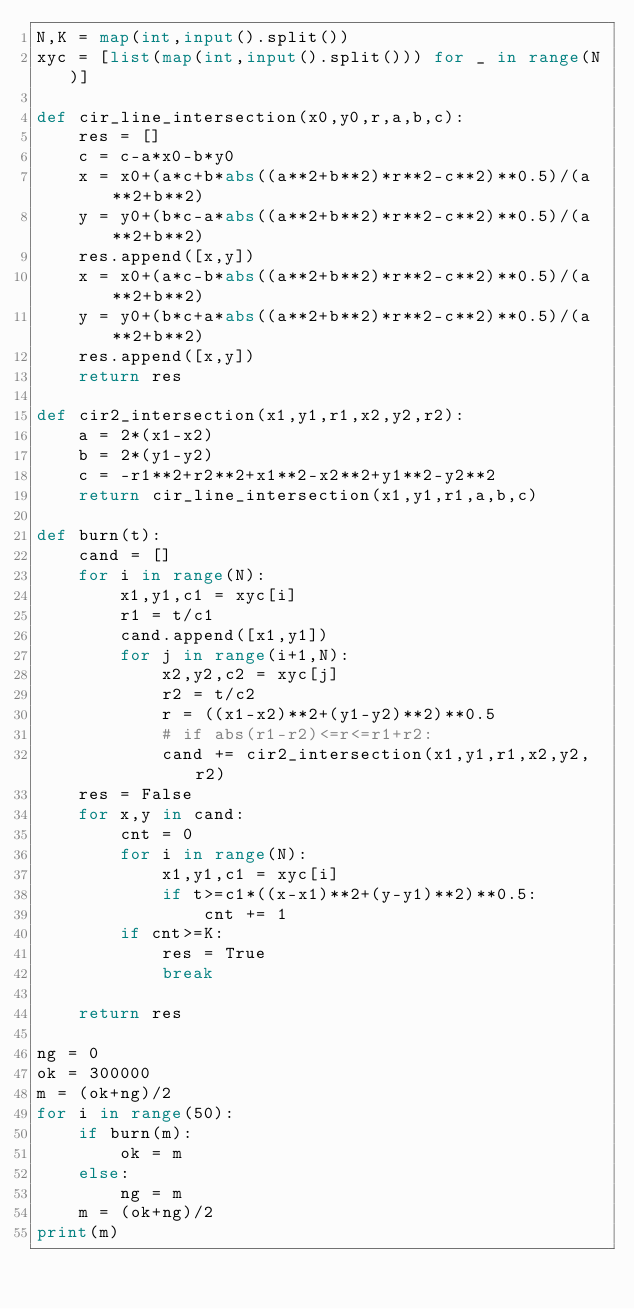Convert code to text. <code><loc_0><loc_0><loc_500><loc_500><_Python_>N,K = map(int,input().split())
xyc = [list(map(int,input().split())) for _ in range(N)]

def cir_line_intersection(x0,y0,r,a,b,c):
    res = []
    c = c-a*x0-b*y0
    x = x0+(a*c+b*abs((a**2+b**2)*r**2-c**2)**0.5)/(a**2+b**2)
    y = y0+(b*c-a*abs((a**2+b**2)*r**2-c**2)**0.5)/(a**2+b**2)
    res.append([x,y])
    x = x0+(a*c-b*abs((a**2+b**2)*r**2-c**2)**0.5)/(a**2+b**2)
    y = y0+(b*c+a*abs((a**2+b**2)*r**2-c**2)**0.5)/(a**2+b**2)
    res.append([x,y])
    return res

def cir2_intersection(x1,y1,r1,x2,y2,r2):
    a = 2*(x1-x2)
    b = 2*(y1-y2)
    c = -r1**2+r2**2+x1**2-x2**2+y1**2-y2**2
    return cir_line_intersection(x1,y1,r1,a,b,c)

def burn(t):
    cand = []
    for i in range(N):
        x1,y1,c1 = xyc[i]
        r1 = t/c1
        cand.append([x1,y1])
        for j in range(i+1,N):
            x2,y2,c2 = xyc[j]
            r2 = t/c2
            r = ((x1-x2)**2+(y1-y2)**2)**0.5
            # if abs(r1-r2)<=r<=r1+r2:
            cand += cir2_intersection(x1,y1,r1,x2,y2,r2)
    res = False
    for x,y in cand:
        cnt = 0
        for i in range(N):
            x1,y1,c1 = xyc[i]
            if t>=c1*((x-x1)**2+(y-y1)**2)**0.5:
                cnt += 1
        if cnt>=K:
            res = True
            break

    return res

ng = 0
ok = 300000
m = (ok+ng)/2
for i in range(50):
    if burn(m):
        ok = m
    else:
        ng = m
    m = (ok+ng)/2
print(m)</code> 